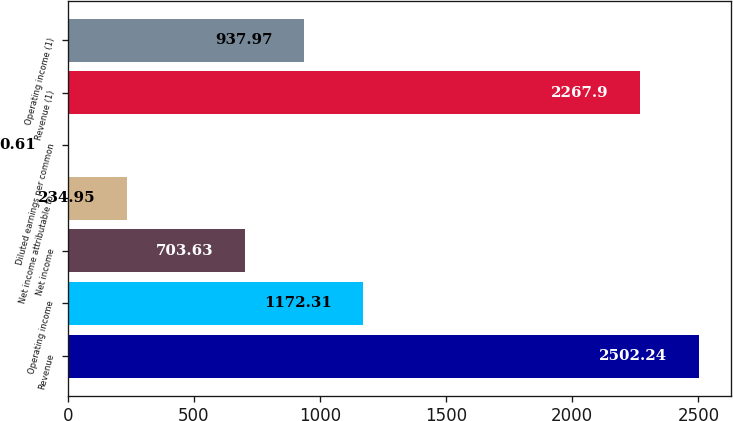<chart> <loc_0><loc_0><loc_500><loc_500><bar_chart><fcel>Revenue<fcel>Operating income<fcel>Net income<fcel>Net income attributable to<fcel>Diluted earnings per common<fcel>Revenue (1)<fcel>Operating income (1)<nl><fcel>2502.24<fcel>1172.31<fcel>703.63<fcel>234.95<fcel>0.61<fcel>2267.9<fcel>937.97<nl></chart> 